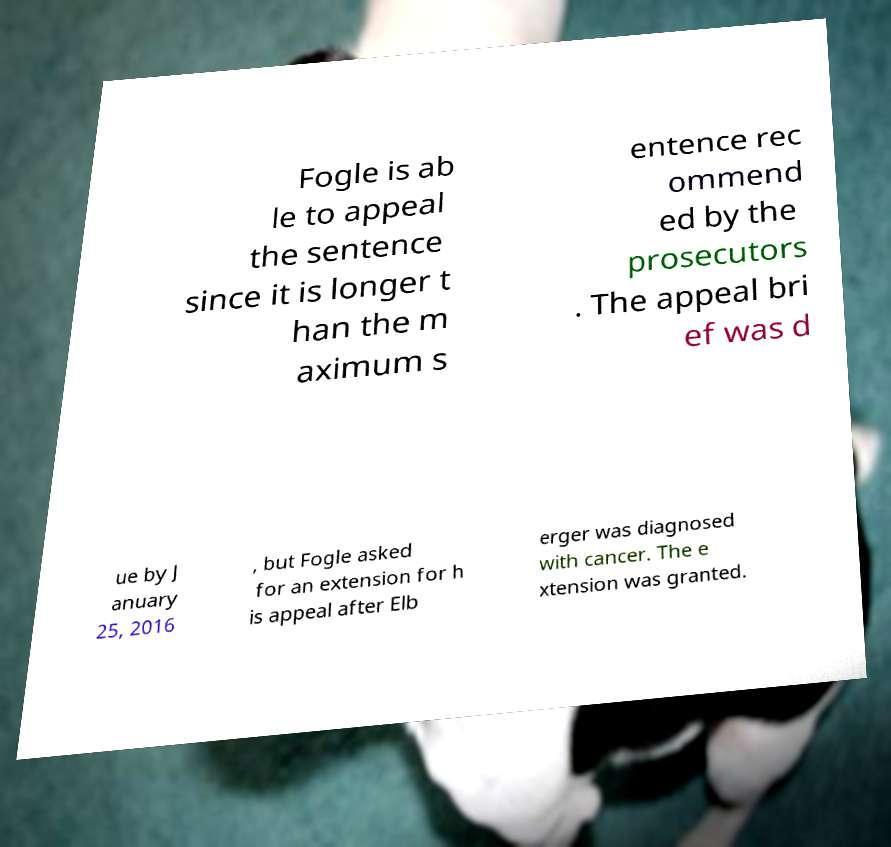Please read and relay the text visible in this image. What does it say? Fogle is ab le to appeal the sentence since it is longer t han the m aximum s entence rec ommend ed by the prosecutors . The appeal bri ef was d ue by J anuary 25, 2016 , but Fogle asked for an extension for h is appeal after Elb erger was diagnosed with cancer. The e xtension was granted. 